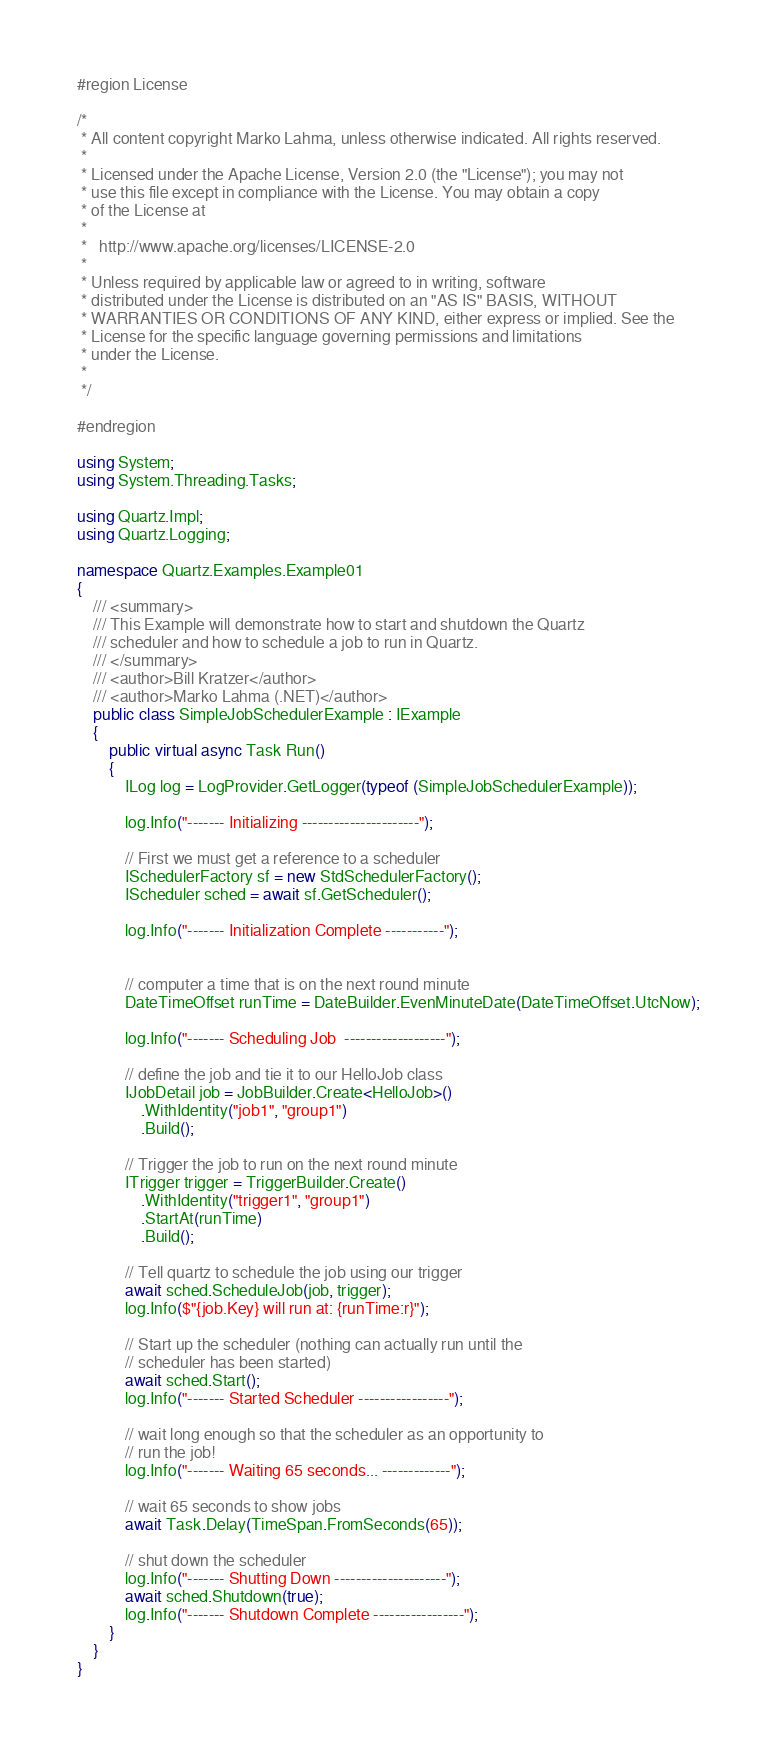Convert code to text. <code><loc_0><loc_0><loc_500><loc_500><_C#_>#region License

/*
 * All content copyright Marko Lahma, unless otherwise indicated. All rights reserved.
 *
 * Licensed under the Apache License, Version 2.0 (the "License"); you may not
 * use this file except in compliance with the License. You may obtain a copy
 * of the License at
 *
 *   http://www.apache.org/licenses/LICENSE-2.0
 *
 * Unless required by applicable law or agreed to in writing, software
 * distributed under the License is distributed on an "AS IS" BASIS, WITHOUT
 * WARRANTIES OR CONDITIONS OF ANY KIND, either express or implied. See the
 * License for the specific language governing permissions and limitations
 * under the License.
 *
 */

#endregion

using System;
using System.Threading.Tasks;

using Quartz.Impl;
using Quartz.Logging;

namespace Quartz.Examples.Example01
{
    /// <summary>
    /// This Example will demonstrate how to start and shutdown the Quartz
    /// scheduler and how to schedule a job to run in Quartz.
    /// </summary>
    /// <author>Bill Kratzer</author>
    /// <author>Marko Lahma (.NET)</author>
    public class SimpleJobSchedulerExample : IExample
    {
        public virtual async Task Run()
        {
            ILog log = LogProvider.GetLogger(typeof (SimpleJobSchedulerExample));

            log.Info("------- Initializing ----------------------");

            // First we must get a reference to a scheduler
            ISchedulerFactory sf = new StdSchedulerFactory();
            IScheduler sched = await sf.GetScheduler();

            log.Info("------- Initialization Complete -----------");


            // computer a time that is on the next round minute
            DateTimeOffset runTime = DateBuilder.EvenMinuteDate(DateTimeOffset.UtcNow);

            log.Info("------- Scheduling Job  -------------------");

            // define the job and tie it to our HelloJob class
            IJobDetail job = JobBuilder.Create<HelloJob>()
                .WithIdentity("job1", "group1")
                .Build();

            // Trigger the job to run on the next round minute
            ITrigger trigger = TriggerBuilder.Create()
                .WithIdentity("trigger1", "group1")
                .StartAt(runTime)
                .Build();

            // Tell quartz to schedule the job using our trigger
            await sched.ScheduleJob(job, trigger);
            log.Info($"{job.Key} will run at: {runTime:r}");

            // Start up the scheduler (nothing can actually run until the
            // scheduler has been started)
            await sched.Start();
            log.Info("------- Started Scheduler -----------------");

            // wait long enough so that the scheduler as an opportunity to
            // run the job!
            log.Info("------- Waiting 65 seconds... -------------");

            // wait 65 seconds to show jobs
            await Task.Delay(TimeSpan.FromSeconds(65));

            // shut down the scheduler
            log.Info("------- Shutting Down ---------------------");
            await sched.Shutdown(true);
            log.Info("------- Shutdown Complete -----------------");
        }
    }
}</code> 